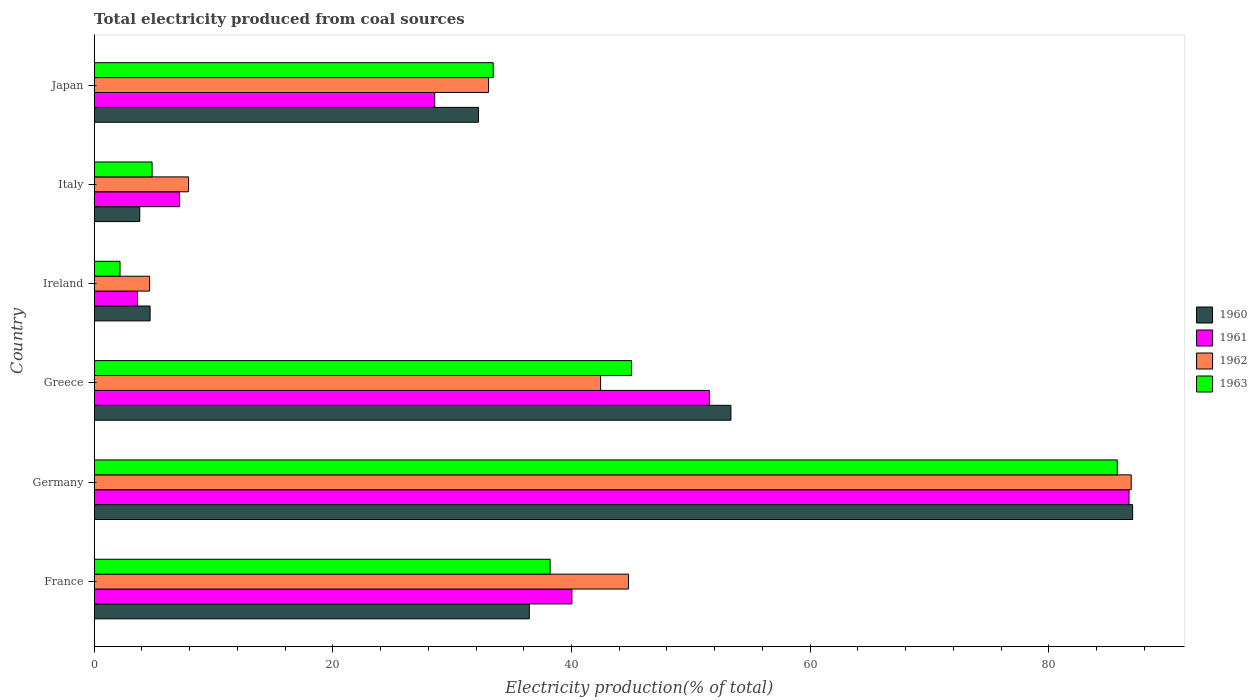How many different coloured bars are there?
Make the answer very short. 4. Are the number of bars per tick equal to the number of legend labels?
Offer a very short reply. Yes. Are the number of bars on each tick of the Y-axis equal?
Ensure brevity in your answer.  Yes. How many bars are there on the 5th tick from the top?
Keep it short and to the point. 4. What is the label of the 6th group of bars from the top?
Keep it short and to the point. France. In how many cases, is the number of bars for a given country not equal to the number of legend labels?
Offer a very short reply. 0. What is the total electricity produced in 1962 in Japan?
Offer a terse response. 33.05. Across all countries, what is the maximum total electricity produced in 1963?
Make the answer very short. 85.74. Across all countries, what is the minimum total electricity produced in 1962?
Provide a succinct answer. 4.64. In which country was the total electricity produced in 1962 maximum?
Make the answer very short. Germany. In which country was the total electricity produced in 1963 minimum?
Your answer should be very brief. Ireland. What is the total total electricity produced in 1960 in the graph?
Give a very brief answer. 217.57. What is the difference between the total electricity produced in 1961 in Greece and that in Japan?
Offer a terse response. 23.02. What is the difference between the total electricity produced in 1960 in Greece and the total electricity produced in 1961 in Germany?
Your response must be concise. -33.36. What is the average total electricity produced in 1962 per country?
Provide a short and direct response. 36.62. What is the difference between the total electricity produced in 1962 and total electricity produced in 1960 in Ireland?
Provide a succinct answer. -0.05. In how many countries, is the total electricity produced in 1963 greater than 80 %?
Make the answer very short. 1. What is the ratio of the total electricity produced in 1962 in Germany to that in Ireland?
Give a very brief answer. 18.73. Is the difference between the total electricity produced in 1962 in Ireland and Japan greater than the difference between the total electricity produced in 1960 in Ireland and Japan?
Provide a short and direct response. No. What is the difference between the highest and the second highest total electricity produced in 1962?
Provide a succinct answer. 42.13. What is the difference between the highest and the lowest total electricity produced in 1962?
Give a very brief answer. 82.27. Is the sum of the total electricity produced in 1963 in Greece and Italy greater than the maximum total electricity produced in 1960 across all countries?
Your answer should be very brief. No. How many bars are there?
Provide a short and direct response. 24. How many countries are there in the graph?
Your answer should be very brief. 6. Where does the legend appear in the graph?
Provide a short and direct response. Center right. What is the title of the graph?
Offer a very short reply. Total electricity produced from coal sources. What is the label or title of the X-axis?
Your response must be concise. Electricity production(% of total). What is the Electricity production(% of total) in 1960 in France?
Keep it short and to the point. 36.47. What is the Electricity production(% of total) in 1961 in France?
Ensure brevity in your answer.  40.03. What is the Electricity production(% of total) in 1962 in France?
Make the answer very short. 44.78. What is the Electricity production(% of total) in 1963 in France?
Offer a terse response. 38.21. What is the Electricity production(% of total) in 1960 in Germany?
Keep it short and to the point. 87.03. What is the Electricity production(% of total) in 1961 in Germany?
Make the answer very short. 86.73. What is the Electricity production(% of total) in 1962 in Germany?
Offer a terse response. 86.91. What is the Electricity production(% of total) in 1963 in Germany?
Your response must be concise. 85.74. What is the Electricity production(% of total) in 1960 in Greece?
Offer a terse response. 53.36. What is the Electricity production(% of total) of 1961 in Greece?
Provide a short and direct response. 51.56. What is the Electricity production(% of total) in 1962 in Greece?
Ensure brevity in your answer.  42.44. What is the Electricity production(% of total) in 1963 in Greece?
Make the answer very short. 45.03. What is the Electricity production(% of total) of 1960 in Ireland?
Offer a very short reply. 4.69. What is the Electricity production(% of total) of 1961 in Ireland?
Give a very brief answer. 3.63. What is the Electricity production(% of total) in 1962 in Ireland?
Offer a terse response. 4.64. What is the Electricity production(% of total) in 1963 in Ireland?
Provide a succinct answer. 2.16. What is the Electricity production(% of total) of 1960 in Italy?
Offer a terse response. 3.82. What is the Electricity production(% of total) in 1961 in Italy?
Provide a succinct answer. 7.15. What is the Electricity production(% of total) of 1962 in Italy?
Ensure brevity in your answer.  7.91. What is the Electricity production(% of total) of 1963 in Italy?
Provide a short and direct response. 4.85. What is the Electricity production(% of total) in 1960 in Japan?
Your response must be concise. 32.21. What is the Electricity production(% of total) in 1961 in Japan?
Provide a succinct answer. 28.54. What is the Electricity production(% of total) of 1962 in Japan?
Ensure brevity in your answer.  33.05. What is the Electricity production(% of total) in 1963 in Japan?
Make the answer very short. 33.44. Across all countries, what is the maximum Electricity production(% of total) of 1960?
Make the answer very short. 87.03. Across all countries, what is the maximum Electricity production(% of total) in 1961?
Offer a terse response. 86.73. Across all countries, what is the maximum Electricity production(% of total) of 1962?
Offer a very short reply. 86.91. Across all countries, what is the maximum Electricity production(% of total) in 1963?
Your answer should be very brief. 85.74. Across all countries, what is the minimum Electricity production(% of total) in 1960?
Provide a short and direct response. 3.82. Across all countries, what is the minimum Electricity production(% of total) of 1961?
Your response must be concise. 3.63. Across all countries, what is the minimum Electricity production(% of total) of 1962?
Provide a succinct answer. 4.64. Across all countries, what is the minimum Electricity production(% of total) of 1963?
Provide a succinct answer. 2.16. What is the total Electricity production(% of total) of 1960 in the graph?
Make the answer very short. 217.57. What is the total Electricity production(% of total) of 1961 in the graph?
Your answer should be compact. 217.64. What is the total Electricity production(% of total) in 1962 in the graph?
Give a very brief answer. 219.72. What is the total Electricity production(% of total) in 1963 in the graph?
Ensure brevity in your answer.  209.44. What is the difference between the Electricity production(% of total) of 1960 in France and that in Germany?
Provide a succinct answer. -50.56. What is the difference between the Electricity production(% of total) in 1961 in France and that in Germany?
Make the answer very short. -46.69. What is the difference between the Electricity production(% of total) in 1962 in France and that in Germany?
Offer a very short reply. -42.13. What is the difference between the Electricity production(% of total) in 1963 in France and that in Germany?
Offer a terse response. -47.53. What is the difference between the Electricity production(% of total) of 1960 in France and that in Greece?
Offer a terse response. -16.89. What is the difference between the Electricity production(% of total) of 1961 in France and that in Greece?
Your answer should be very brief. -11.53. What is the difference between the Electricity production(% of total) in 1962 in France and that in Greece?
Offer a very short reply. 2.34. What is the difference between the Electricity production(% of total) of 1963 in France and that in Greece?
Make the answer very short. -6.82. What is the difference between the Electricity production(% of total) of 1960 in France and that in Ireland?
Your answer should be compact. 31.78. What is the difference between the Electricity production(% of total) in 1961 in France and that in Ireland?
Offer a very short reply. 36.41. What is the difference between the Electricity production(% of total) of 1962 in France and that in Ireland?
Your answer should be very brief. 40.14. What is the difference between the Electricity production(% of total) of 1963 in France and that in Ireland?
Offer a terse response. 36.05. What is the difference between the Electricity production(% of total) in 1960 in France and that in Italy?
Keep it short and to the point. 32.65. What is the difference between the Electricity production(% of total) in 1961 in France and that in Italy?
Offer a very short reply. 32.88. What is the difference between the Electricity production(% of total) of 1962 in France and that in Italy?
Offer a very short reply. 36.87. What is the difference between the Electricity production(% of total) of 1963 in France and that in Italy?
Keep it short and to the point. 33.36. What is the difference between the Electricity production(% of total) of 1960 in France and that in Japan?
Provide a short and direct response. 4.26. What is the difference between the Electricity production(% of total) in 1961 in France and that in Japan?
Your answer should be compact. 11.5. What is the difference between the Electricity production(% of total) of 1962 in France and that in Japan?
Your response must be concise. 11.73. What is the difference between the Electricity production(% of total) of 1963 in France and that in Japan?
Provide a succinct answer. 4.77. What is the difference between the Electricity production(% of total) in 1960 in Germany and that in Greece?
Provide a short and direct response. 33.67. What is the difference between the Electricity production(% of total) in 1961 in Germany and that in Greece?
Your answer should be very brief. 35.16. What is the difference between the Electricity production(% of total) in 1962 in Germany and that in Greece?
Your answer should be compact. 44.47. What is the difference between the Electricity production(% of total) in 1963 in Germany and that in Greece?
Ensure brevity in your answer.  40.71. What is the difference between the Electricity production(% of total) in 1960 in Germany and that in Ireland?
Your response must be concise. 82.34. What is the difference between the Electricity production(% of total) in 1961 in Germany and that in Ireland?
Offer a very short reply. 83.1. What is the difference between the Electricity production(% of total) in 1962 in Germany and that in Ireland?
Make the answer very short. 82.27. What is the difference between the Electricity production(% of total) of 1963 in Germany and that in Ireland?
Make the answer very short. 83.58. What is the difference between the Electricity production(% of total) in 1960 in Germany and that in Italy?
Offer a very short reply. 83.21. What is the difference between the Electricity production(% of total) of 1961 in Germany and that in Italy?
Your answer should be compact. 79.57. What is the difference between the Electricity production(% of total) of 1962 in Germany and that in Italy?
Offer a very short reply. 79. What is the difference between the Electricity production(% of total) of 1963 in Germany and that in Italy?
Offer a very short reply. 80.89. What is the difference between the Electricity production(% of total) in 1960 in Germany and that in Japan?
Your answer should be very brief. 54.82. What is the difference between the Electricity production(% of total) of 1961 in Germany and that in Japan?
Offer a terse response. 58.19. What is the difference between the Electricity production(% of total) of 1962 in Germany and that in Japan?
Provide a succinct answer. 53.86. What is the difference between the Electricity production(% of total) in 1963 in Germany and that in Japan?
Ensure brevity in your answer.  52.3. What is the difference between the Electricity production(% of total) in 1960 in Greece and that in Ireland?
Provide a succinct answer. 48.68. What is the difference between the Electricity production(% of total) of 1961 in Greece and that in Ireland?
Provide a short and direct response. 47.93. What is the difference between the Electricity production(% of total) in 1962 in Greece and that in Ireland?
Give a very brief answer. 37.8. What is the difference between the Electricity production(% of total) of 1963 in Greece and that in Ireland?
Your answer should be very brief. 42.87. What is the difference between the Electricity production(% of total) of 1960 in Greece and that in Italy?
Give a very brief answer. 49.54. What is the difference between the Electricity production(% of total) of 1961 in Greece and that in Italy?
Offer a terse response. 44.41. What is the difference between the Electricity production(% of total) in 1962 in Greece and that in Italy?
Your answer should be compact. 34.53. What is the difference between the Electricity production(% of total) in 1963 in Greece and that in Italy?
Ensure brevity in your answer.  40.18. What is the difference between the Electricity production(% of total) in 1960 in Greece and that in Japan?
Your response must be concise. 21.15. What is the difference between the Electricity production(% of total) in 1961 in Greece and that in Japan?
Provide a short and direct response. 23.02. What is the difference between the Electricity production(% of total) in 1962 in Greece and that in Japan?
Your answer should be very brief. 9.39. What is the difference between the Electricity production(% of total) of 1963 in Greece and that in Japan?
Your answer should be very brief. 11.59. What is the difference between the Electricity production(% of total) of 1960 in Ireland and that in Italy?
Provide a short and direct response. 0.87. What is the difference between the Electricity production(% of total) in 1961 in Ireland and that in Italy?
Your answer should be very brief. -3.53. What is the difference between the Electricity production(% of total) in 1962 in Ireland and that in Italy?
Offer a terse response. -3.27. What is the difference between the Electricity production(% of total) of 1963 in Ireland and that in Italy?
Your answer should be very brief. -2.69. What is the difference between the Electricity production(% of total) in 1960 in Ireland and that in Japan?
Your answer should be very brief. -27.52. What is the difference between the Electricity production(% of total) in 1961 in Ireland and that in Japan?
Make the answer very short. -24.91. What is the difference between the Electricity production(% of total) in 1962 in Ireland and that in Japan?
Your answer should be very brief. -28.41. What is the difference between the Electricity production(% of total) in 1963 in Ireland and that in Japan?
Give a very brief answer. -31.28. What is the difference between the Electricity production(% of total) in 1960 in Italy and that in Japan?
Provide a short and direct response. -28.39. What is the difference between the Electricity production(% of total) in 1961 in Italy and that in Japan?
Your response must be concise. -21.38. What is the difference between the Electricity production(% of total) in 1962 in Italy and that in Japan?
Your answer should be very brief. -25.14. What is the difference between the Electricity production(% of total) of 1963 in Italy and that in Japan?
Provide a short and direct response. -28.59. What is the difference between the Electricity production(% of total) of 1960 in France and the Electricity production(% of total) of 1961 in Germany?
Provide a succinct answer. -50.26. What is the difference between the Electricity production(% of total) in 1960 in France and the Electricity production(% of total) in 1962 in Germany?
Provide a short and direct response. -50.44. What is the difference between the Electricity production(% of total) in 1960 in France and the Electricity production(% of total) in 1963 in Germany?
Provide a short and direct response. -49.27. What is the difference between the Electricity production(% of total) of 1961 in France and the Electricity production(% of total) of 1962 in Germany?
Give a very brief answer. -46.87. What is the difference between the Electricity production(% of total) of 1961 in France and the Electricity production(% of total) of 1963 in Germany?
Your response must be concise. -45.71. What is the difference between the Electricity production(% of total) in 1962 in France and the Electricity production(% of total) in 1963 in Germany?
Offer a terse response. -40.97. What is the difference between the Electricity production(% of total) in 1960 in France and the Electricity production(% of total) in 1961 in Greece?
Offer a terse response. -15.09. What is the difference between the Electricity production(% of total) in 1960 in France and the Electricity production(% of total) in 1962 in Greece?
Offer a very short reply. -5.97. What is the difference between the Electricity production(% of total) in 1960 in France and the Electricity production(% of total) in 1963 in Greece?
Keep it short and to the point. -8.56. What is the difference between the Electricity production(% of total) of 1961 in France and the Electricity production(% of total) of 1962 in Greece?
Provide a succinct answer. -2.41. What is the difference between the Electricity production(% of total) in 1961 in France and the Electricity production(% of total) in 1963 in Greece?
Offer a terse response. -5. What is the difference between the Electricity production(% of total) of 1962 in France and the Electricity production(% of total) of 1963 in Greece?
Make the answer very short. -0.25. What is the difference between the Electricity production(% of total) in 1960 in France and the Electricity production(% of total) in 1961 in Ireland?
Provide a short and direct response. 32.84. What is the difference between the Electricity production(% of total) of 1960 in France and the Electricity production(% of total) of 1962 in Ireland?
Give a very brief answer. 31.83. What is the difference between the Electricity production(% of total) of 1960 in France and the Electricity production(% of total) of 1963 in Ireland?
Your response must be concise. 34.3. What is the difference between the Electricity production(% of total) of 1961 in France and the Electricity production(% of total) of 1962 in Ireland?
Keep it short and to the point. 35.39. What is the difference between the Electricity production(% of total) of 1961 in France and the Electricity production(% of total) of 1963 in Ireland?
Provide a short and direct response. 37.87. What is the difference between the Electricity production(% of total) of 1962 in France and the Electricity production(% of total) of 1963 in Ireland?
Provide a succinct answer. 42.61. What is the difference between the Electricity production(% of total) in 1960 in France and the Electricity production(% of total) in 1961 in Italy?
Make the answer very short. 29.31. What is the difference between the Electricity production(% of total) in 1960 in France and the Electricity production(% of total) in 1962 in Italy?
Your response must be concise. 28.56. What is the difference between the Electricity production(% of total) in 1960 in France and the Electricity production(% of total) in 1963 in Italy?
Offer a very short reply. 31.62. What is the difference between the Electricity production(% of total) in 1961 in France and the Electricity production(% of total) in 1962 in Italy?
Give a very brief answer. 32.13. What is the difference between the Electricity production(% of total) in 1961 in France and the Electricity production(% of total) in 1963 in Italy?
Your answer should be very brief. 35.18. What is the difference between the Electricity production(% of total) of 1962 in France and the Electricity production(% of total) of 1963 in Italy?
Your answer should be very brief. 39.93. What is the difference between the Electricity production(% of total) of 1960 in France and the Electricity production(% of total) of 1961 in Japan?
Offer a terse response. 7.93. What is the difference between the Electricity production(% of total) of 1960 in France and the Electricity production(% of total) of 1962 in Japan?
Make the answer very short. 3.42. What is the difference between the Electricity production(% of total) of 1960 in France and the Electricity production(% of total) of 1963 in Japan?
Offer a very short reply. 3.02. What is the difference between the Electricity production(% of total) in 1961 in France and the Electricity production(% of total) in 1962 in Japan?
Ensure brevity in your answer.  6.99. What is the difference between the Electricity production(% of total) of 1961 in France and the Electricity production(% of total) of 1963 in Japan?
Your answer should be very brief. 6.59. What is the difference between the Electricity production(% of total) of 1962 in France and the Electricity production(% of total) of 1963 in Japan?
Provide a short and direct response. 11.33. What is the difference between the Electricity production(% of total) of 1960 in Germany and the Electricity production(% of total) of 1961 in Greece?
Provide a succinct answer. 35.47. What is the difference between the Electricity production(% of total) in 1960 in Germany and the Electricity production(% of total) in 1962 in Greece?
Provide a short and direct response. 44.59. What is the difference between the Electricity production(% of total) in 1960 in Germany and the Electricity production(% of total) in 1963 in Greece?
Ensure brevity in your answer.  42. What is the difference between the Electricity production(% of total) of 1961 in Germany and the Electricity production(% of total) of 1962 in Greece?
Offer a very short reply. 44.29. What is the difference between the Electricity production(% of total) in 1961 in Germany and the Electricity production(% of total) in 1963 in Greece?
Provide a succinct answer. 41.69. What is the difference between the Electricity production(% of total) in 1962 in Germany and the Electricity production(% of total) in 1963 in Greece?
Ensure brevity in your answer.  41.88. What is the difference between the Electricity production(% of total) of 1960 in Germany and the Electricity production(% of total) of 1961 in Ireland?
Provide a succinct answer. 83.4. What is the difference between the Electricity production(% of total) in 1960 in Germany and the Electricity production(% of total) in 1962 in Ireland?
Give a very brief answer. 82.39. What is the difference between the Electricity production(% of total) of 1960 in Germany and the Electricity production(% of total) of 1963 in Ireland?
Give a very brief answer. 84.86. What is the difference between the Electricity production(% of total) of 1961 in Germany and the Electricity production(% of total) of 1962 in Ireland?
Offer a very short reply. 82.08. What is the difference between the Electricity production(% of total) of 1961 in Germany and the Electricity production(% of total) of 1963 in Ireland?
Ensure brevity in your answer.  84.56. What is the difference between the Electricity production(% of total) of 1962 in Germany and the Electricity production(% of total) of 1963 in Ireland?
Make the answer very short. 84.74. What is the difference between the Electricity production(% of total) in 1960 in Germany and the Electricity production(% of total) in 1961 in Italy?
Make the answer very short. 79.87. What is the difference between the Electricity production(% of total) in 1960 in Germany and the Electricity production(% of total) in 1962 in Italy?
Your response must be concise. 79.12. What is the difference between the Electricity production(% of total) of 1960 in Germany and the Electricity production(% of total) of 1963 in Italy?
Your answer should be very brief. 82.18. What is the difference between the Electricity production(% of total) in 1961 in Germany and the Electricity production(% of total) in 1962 in Italy?
Make the answer very short. 78.82. What is the difference between the Electricity production(% of total) of 1961 in Germany and the Electricity production(% of total) of 1963 in Italy?
Give a very brief answer. 81.87. What is the difference between the Electricity production(% of total) of 1962 in Germany and the Electricity production(% of total) of 1963 in Italy?
Offer a very short reply. 82.06. What is the difference between the Electricity production(% of total) of 1960 in Germany and the Electricity production(% of total) of 1961 in Japan?
Your answer should be very brief. 58.49. What is the difference between the Electricity production(% of total) of 1960 in Germany and the Electricity production(% of total) of 1962 in Japan?
Your answer should be very brief. 53.98. What is the difference between the Electricity production(% of total) in 1960 in Germany and the Electricity production(% of total) in 1963 in Japan?
Keep it short and to the point. 53.59. What is the difference between the Electricity production(% of total) of 1961 in Germany and the Electricity production(% of total) of 1962 in Japan?
Provide a short and direct response. 53.68. What is the difference between the Electricity production(% of total) of 1961 in Germany and the Electricity production(% of total) of 1963 in Japan?
Provide a succinct answer. 53.28. What is the difference between the Electricity production(% of total) in 1962 in Germany and the Electricity production(% of total) in 1963 in Japan?
Your answer should be compact. 53.47. What is the difference between the Electricity production(% of total) of 1960 in Greece and the Electricity production(% of total) of 1961 in Ireland?
Your answer should be compact. 49.73. What is the difference between the Electricity production(% of total) in 1960 in Greece and the Electricity production(% of total) in 1962 in Ireland?
Your answer should be very brief. 48.72. What is the difference between the Electricity production(% of total) of 1960 in Greece and the Electricity production(% of total) of 1963 in Ireland?
Provide a succinct answer. 51.2. What is the difference between the Electricity production(% of total) of 1961 in Greece and the Electricity production(% of total) of 1962 in Ireland?
Provide a short and direct response. 46.92. What is the difference between the Electricity production(% of total) of 1961 in Greece and the Electricity production(% of total) of 1963 in Ireland?
Your answer should be compact. 49.4. What is the difference between the Electricity production(% of total) of 1962 in Greece and the Electricity production(% of total) of 1963 in Ireland?
Offer a very short reply. 40.27. What is the difference between the Electricity production(% of total) in 1960 in Greece and the Electricity production(% of total) in 1961 in Italy?
Your answer should be compact. 46.21. What is the difference between the Electricity production(% of total) in 1960 in Greece and the Electricity production(% of total) in 1962 in Italy?
Offer a terse response. 45.45. What is the difference between the Electricity production(% of total) in 1960 in Greece and the Electricity production(% of total) in 1963 in Italy?
Keep it short and to the point. 48.51. What is the difference between the Electricity production(% of total) of 1961 in Greece and the Electricity production(% of total) of 1962 in Italy?
Ensure brevity in your answer.  43.65. What is the difference between the Electricity production(% of total) of 1961 in Greece and the Electricity production(% of total) of 1963 in Italy?
Provide a short and direct response. 46.71. What is the difference between the Electricity production(% of total) of 1962 in Greece and the Electricity production(% of total) of 1963 in Italy?
Keep it short and to the point. 37.59. What is the difference between the Electricity production(% of total) of 1960 in Greece and the Electricity production(% of total) of 1961 in Japan?
Offer a terse response. 24.82. What is the difference between the Electricity production(% of total) in 1960 in Greece and the Electricity production(% of total) in 1962 in Japan?
Your answer should be compact. 20.31. What is the difference between the Electricity production(% of total) of 1960 in Greece and the Electricity production(% of total) of 1963 in Japan?
Your answer should be very brief. 19.92. What is the difference between the Electricity production(% of total) of 1961 in Greece and the Electricity production(% of total) of 1962 in Japan?
Offer a very short reply. 18.51. What is the difference between the Electricity production(% of total) in 1961 in Greece and the Electricity production(% of total) in 1963 in Japan?
Give a very brief answer. 18.12. What is the difference between the Electricity production(% of total) of 1962 in Greece and the Electricity production(% of total) of 1963 in Japan?
Offer a very short reply. 9. What is the difference between the Electricity production(% of total) of 1960 in Ireland and the Electricity production(% of total) of 1961 in Italy?
Provide a short and direct response. -2.47. What is the difference between the Electricity production(% of total) of 1960 in Ireland and the Electricity production(% of total) of 1962 in Italy?
Ensure brevity in your answer.  -3.22. What is the difference between the Electricity production(% of total) of 1960 in Ireland and the Electricity production(% of total) of 1963 in Italy?
Provide a succinct answer. -0.17. What is the difference between the Electricity production(% of total) in 1961 in Ireland and the Electricity production(% of total) in 1962 in Italy?
Offer a very short reply. -4.28. What is the difference between the Electricity production(% of total) in 1961 in Ireland and the Electricity production(% of total) in 1963 in Italy?
Provide a succinct answer. -1.22. What is the difference between the Electricity production(% of total) in 1962 in Ireland and the Electricity production(% of total) in 1963 in Italy?
Offer a very short reply. -0.21. What is the difference between the Electricity production(% of total) of 1960 in Ireland and the Electricity production(% of total) of 1961 in Japan?
Offer a very short reply. -23.85. What is the difference between the Electricity production(% of total) in 1960 in Ireland and the Electricity production(% of total) in 1962 in Japan?
Provide a short and direct response. -28.36. What is the difference between the Electricity production(% of total) of 1960 in Ireland and the Electricity production(% of total) of 1963 in Japan?
Give a very brief answer. -28.76. What is the difference between the Electricity production(% of total) of 1961 in Ireland and the Electricity production(% of total) of 1962 in Japan?
Keep it short and to the point. -29.42. What is the difference between the Electricity production(% of total) of 1961 in Ireland and the Electricity production(% of total) of 1963 in Japan?
Provide a succinct answer. -29.82. What is the difference between the Electricity production(% of total) in 1962 in Ireland and the Electricity production(% of total) in 1963 in Japan?
Ensure brevity in your answer.  -28.8. What is the difference between the Electricity production(% of total) of 1960 in Italy and the Electricity production(% of total) of 1961 in Japan?
Provide a succinct answer. -24.72. What is the difference between the Electricity production(% of total) of 1960 in Italy and the Electricity production(% of total) of 1962 in Japan?
Make the answer very short. -29.23. What is the difference between the Electricity production(% of total) in 1960 in Italy and the Electricity production(% of total) in 1963 in Japan?
Provide a short and direct response. -29.63. What is the difference between the Electricity production(% of total) of 1961 in Italy and the Electricity production(% of total) of 1962 in Japan?
Keep it short and to the point. -25.89. What is the difference between the Electricity production(% of total) of 1961 in Italy and the Electricity production(% of total) of 1963 in Japan?
Your answer should be compact. -26.29. What is the difference between the Electricity production(% of total) of 1962 in Italy and the Electricity production(% of total) of 1963 in Japan?
Offer a terse response. -25.53. What is the average Electricity production(% of total) in 1960 per country?
Provide a short and direct response. 36.26. What is the average Electricity production(% of total) of 1961 per country?
Your answer should be compact. 36.27. What is the average Electricity production(% of total) in 1962 per country?
Your response must be concise. 36.62. What is the average Electricity production(% of total) in 1963 per country?
Provide a succinct answer. 34.91. What is the difference between the Electricity production(% of total) in 1960 and Electricity production(% of total) in 1961 in France?
Ensure brevity in your answer.  -3.57. What is the difference between the Electricity production(% of total) in 1960 and Electricity production(% of total) in 1962 in France?
Give a very brief answer. -8.31. What is the difference between the Electricity production(% of total) in 1960 and Electricity production(% of total) in 1963 in France?
Offer a very short reply. -1.74. What is the difference between the Electricity production(% of total) of 1961 and Electricity production(% of total) of 1962 in France?
Your answer should be very brief. -4.74. What is the difference between the Electricity production(% of total) of 1961 and Electricity production(% of total) of 1963 in France?
Ensure brevity in your answer.  1.82. What is the difference between the Electricity production(% of total) in 1962 and Electricity production(% of total) in 1963 in France?
Give a very brief answer. 6.57. What is the difference between the Electricity production(% of total) in 1960 and Electricity production(% of total) in 1961 in Germany?
Offer a very short reply. 0.3. What is the difference between the Electricity production(% of total) of 1960 and Electricity production(% of total) of 1962 in Germany?
Provide a short and direct response. 0.12. What is the difference between the Electricity production(% of total) in 1960 and Electricity production(% of total) in 1963 in Germany?
Give a very brief answer. 1.29. What is the difference between the Electricity production(% of total) of 1961 and Electricity production(% of total) of 1962 in Germany?
Make the answer very short. -0.18. What is the difference between the Electricity production(% of total) in 1961 and Electricity production(% of total) in 1963 in Germany?
Ensure brevity in your answer.  0.98. What is the difference between the Electricity production(% of total) in 1962 and Electricity production(% of total) in 1963 in Germany?
Your answer should be compact. 1.17. What is the difference between the Electricity production(% of total) of 1960 and Electricity production(% of total) of 1961 in Greece?
Offer a very short reply. 1.8. What is the difference between the Electricity production(% of total) of 1960 and Electricity production(% of total) of 1962 in Greece?
Your response must be concise. 10.92. What is the difference between the Electricity production(% of total) of 1960 and Electricity production(% of total) of 1963 in Greece?
Provide a short and direct response. 8.33. What is the difference between the Electricity production(% of total) in 1961 and Electricity production(% of total) in 1962 in Greece?
Provide a short and direct response. 9.12. What is the difference between the Electricity production(% of total) of 1961 and Electricity production(% of total) of 1963 in Greece?
Provide a short and direct response. 6.53. What is the difference between the Electricity production(% of total) of 1962 and Electricity production(% of total) of 1963 in Greece?
Offer a terse response. -2.59. What is the difference between the Electricity production(% of total) in 1960 and Electricity production(% of total) in 1961 in Ireland?
Provide a succinct answer. 1.06. What is the difference between the Electricity production(% of total) in 1960 and Electricity production(% of total) in 1962 in Ireland?
Your response must be concise. 0.05. What is the difference between the Electricity production(% of total) of 1960 and Electricity production(% of total) of 1963 in Ireland?
Offer a terse response. 2.52. What is the difference between the Electricity production(% of total) of 1961 and Electricity production(% of total) of 1962 in Ireland?
Keep it short and to the point. -1.01. What is the difference between the Electricity production(% of total) of 1961 and Electricity production(% of total) of 1963 in Ireland?
Provide a short and direct response. 1.46. What is the difference between the Electricity production(% of total) in 1962 and Electricity production(% of total) in 1963 in Ireland?
Give a very brief answer. 2.48. What is the difference between the Electricity production(% of total) in 1960 and Electricity production(% of total) in 1961 in Italy?
Offer a terse response. -3.34. What is the difference between the Electricity production(% of total) in 1960 and Electricity production(% of total) in 1962 in Italy?
Give a very brief answer. -4.09. What is the difference between the Electricity production(% of total) in 1960 and Electricity production(% of total) in 1963 in Italy?
Make the answer very short. -1.03. What is the difference between the Electricity production(% of total) of 1961 and Electricity production(% of total) of 1962 in Italy?
Your answer should be compact. -0.75. What is the difference between the Electricity production(% of total) of 1961 and Electricity production(% of total) of 1963 in Italy?
Ensure brevity in your answer.  2.3. What is the difference between the Electricity production(% of total) in 1962 and Electricity production(% of total) in 1963 in Italy?
Give a very brief answer. 3.06. What is the difference between the Electricity production(% of total) of 1960 and Electricity production(% of total) of 1961 in Japan?
Your response must be concise. 3.67. What is the difference between the Electricity production(% of total) in 1960 and Electricity production(% of total) in 1962 in Japan?
Provide a short and direct response. -0.84. What is the difference between the Electricity production(% of total) of 1960 and Electricity production(% of total) of 1963 in Japan?
Keep it short and to the point. -1.24. What is the difference between the Electricity production(% of total) in 1961 and Electricity production(% of total) in 1962 in Japan?
Offer a terse response. -4.51. What is the difference between the Electricity production(% of total) in 1961 and Electricity production(% of total) in 1963 in Japan?
Ensure brevity in your answer.  -4.9. What is the difference between the Electricity production(% of total) in 1962 and Electricity production(% of total) in 1963 in Japan?
Offer a terse response. -0.4. What is the ratio of the Electricity production(% of total) of 1960 in France to that in Germany?
Provide a succinct answer. 0.42. What is the ratio of the Electricity production(% of total) of 1961 in France to that in Germany?
Provide a short and direct response. 0.46. What is the ratio of the Electricity production(% of total) of 1962 in France to that in Germany?
Your answer should be compact. 0.52. What is the ratio of the Electricity production(% of total) in 1963 in France to that in Germany?
Provide a short and direct response. 0.45. What is the ratio of the Electricity production(% of total) of 1960 in France to that in Greece?
Your answer should be compact. 0.68. What is the ratio of the Electricity production(% of total) of 1961 in France to that in Greece?
Keep it short and to the point. 0.78. What is the ratio of the Electricity production(% of total) in 1962 in France to that in Greece?
Provide a succinct answer. 1.06. What is the ratio of the Electricity production(% of total) of 1963 in France to that in Greece?
Your response must be concise. 0.85. What is the ratio of the Electricity production(% of total) of 1960 in France to that in Ireland?
Keep it short and to the point. 7.78. What is the ratio of the Electricity production(% of total) of 1961 in France to that in Ireland?
Give a very brief answer. 11.03. What is the ratio of the Electricity production(% of total) in 1962 in France to that in Ireland?
Provide a succinct answer. 9.65. What is the ratio of the Electricity production(% of total) of 1963 in France to that in Ireland?
Provide a short and direct response. 17.65. What is the ratio of the Electricity production(% of total) in 1960 in France to that in Italy?
Make the answer very short. 9.55. What is the ratio of the Electricity production(% of total) in 1961 in France to that in Italy?
Your answer should be very brief. 5.6. What is the ratio of the Electricity production(% of total) in 1962 in France to that in Italy?
Your answer should be compact. 5.66. What is the ratio of the Electricity production(% of total) of 1963 in France to that in Italy?
Give a very brief answer. 7.88. What is the ratio of the Electricity production(% of total) of 1960 in France to that in Japan?
Offer a very short reply. 1.13. What is the ratio of the Electricity production(% of total) in 1961 in France to that in Japan?
Provide a short and direct response. 1.4. What is the ratio of the Electricity production(% of total) in 1962 in France to that in Japan?
Provide a short and direct response. 1.35. What is the ratio of the Electricity production(% of total) of 1963 in France to that in Japan?
Give a very brief answer. 1.14. What is the ratio of the Electricity production(% of total) in 1960 in Germany to that in Greece?
Offer a very short reply. 1.63. What is the ratio of the Electricity production(% of total) of 1961 in Germany to that in Greece?
Make the answer very short. 1.68. What is the ratio of the Electricity production(% of total) of 1962 in Germany to that in Greece?
Give a very brief answer. 2.05. What is the ratio of the Electricity production(% of total) of 1963 in Germany to that in Greece?
Ensure brevity in your answer.  1.9. What is the ratio of the Electricity production(% of total) in 1960 in Germany to that in Ireland?
Provide a succinct answer. 18.57. What is the ratio of the Electricity production(% of total) in 1961 in Germany to that in Ireland?
Give a very brief answer. 23.9. What is the ratio of the Electricity production(% of total) of 1962 in Germany to that in Ireland?
Provide a succinct answer. 18.73. What is the ratio of the Electricity production(% of total) of 1963 in Germany to that in Ireland?
Make the answer very short. 39.6. What is the ratio of the Electricity production(% of total) of 1960 in Germany to that in Italy?
Give a very brief answer. 22.79. What is the ratio of the Electricity production(% of total) in 1961 in Germany to that in Italy?
Provide a short and direct response. 12.12. What is the ratio of the Electricity production(% of total) in 1962 in Germany to that in Italy?
Offer a terse response. 10.99. What is the ratio of the Electricity production(% of total) of 1963 in Germany to that in Italy?
Provide a short and direct response. 17.67. What is the ratio of the Electricity production(% of total) of 1960 in Germany to that in Japan?
Offer a very short reply. 2.7. What is the ratio of the Electricity production(% of total) of 1961 in Germany to that in Japan?
Give a very brief answer. 3.04. What is the ratio of the Electricity production(% of total) of 1962 in Germany to that in Japan?
Keep it short and to the point. 2.63. What is the ratio of the Electricity production(% of total) in 1963 in Germany to that in Japan?
Provide a short and direct response. 2.56. What is the ratio of the Electricity production(% of total) of 1960 in Greece to that in Ireland?
Offer a terse response. 11.39. What is the ratio of the Electricity production(% of total) in 1961 in Greece to that in Ireland?
Make the answer very short. 14.21. What is the ratio of the Electricity production(% of total) in 1962 in Greece to that in Ireland?
Offer a terse response. 9.14. What is the ratio of the Electricity production(% of total) in 1963 in Greece to that in Ireland?
Keep it short and to the point. 20.8. What is the ratio of the Electricity production(% of total) of 1960 in Greece to that in Italy?
Give a very brief answer. 13.97. What is the ratio of the Electricity production(% of total) in 1961 in Greece to that in Italy?
Your answer should be very brief. 7.21. What is the ratio of the Electricity production(% of total) of 1962 in Greece to that in Italy?
Keep it short and to the point. 5.37. What is the ratio of the Electricity production(% of total) in 1963 in Greece to that in Italy?
Your answer should be very brief. 9.28. What is the ratio of the Electricity production(% of total) in 1960 in Greece to that in Japan?
Offer a terse response. 1.66. What is the ratio of the Electricity production(% of total) of 1961 in Greece to that in Japan?
Provide a short and direct response. 1.81. What is the ratio of the Electricity production(% of total) of 1962 in Greece to that in Japan?
Ensure brevity in your answer.  1.28. What is the ratio of the Electricity production(% of total) in 1963 in Greece to that in Japan?
Offer a very short reply. 1.35. What is the ratio of the Electricity production(% of total) in 1960 in Ireland to that in Italy?
Make the answer very short. 1.23. What is the ratio of the Electricity production(% of total) in 1961 in Ireland to that in Italy?
Offer a terse response. 0.51. What is the ratio of the Electricity production(% of total) in 1962 in Ireland to that in Italy?
Keep it short and to the point. 0.59. What is the ratio of the Electricity production(% of total) of 1963 in Ireland to that in Italy?
Your response must be concise. 0.45. What is the ratio of the Electricity production(% of total) of 1960 in Ireland to that in Japan?
Provide a succinct answer. 0.15. What is the ratio of the Electricity production(% of total) in 1961 in Ireland to that in Japan?
Your response must be concise. 0.13. What is the ratio of the Electricity production(% of total) in 1962 in Ireland to that in Japan?
Provide a succinct answer. 0.14. What is the ratio of the Electricity production(% of total) in 1963 in Ireland to that in Japan?
Keep it short and to the point. 0.06. What is the ratio of the Electricity production(% of total) in 1960 in Italy to that in Japan?
Ensure brevity in your answer.  0.12. What is the ratio of the Electricity production(% of total) in 1961 in Italy to that in Japan?
Provide a short and direct response. 0.25. What is the ratio of the Electricity production(% of total) of 1962 in Italy to that in Japan?
Your response must be concise. 0.24. What is the ratio of the Electricity production(% of total) of 1963 in Italy to that in Japan?
Ensure brevity in your answer.  0.15. What is the difference between the highest and the second highest Electricity production(% of total) in 1960?
Keep it short and to the point. 33.67. What is the difference between the highest and the second highest Electricity production(% of total) in 1961?
Your answer should be compact. 35.16. What is the difference between the highest and the second highest Electricity production(% of total) in 1962?
Offer a very short reply. 42.13. What is the difference between the highest and the second highest Electricity production(% of total) of 1963?
Ensure brevity in your answer.  40.71. What is the difference between the highest and the lowest Electricity production(% of total) in 1960?
Make the answer very short. 83.21. What is the difference between the highest and the lowest Electricity production(% of total) of 1961?
Your response must be concise. 83.1. What is the difference between the highest and the lowest Electricity production(% of total) in 1962?
Ensure brevity in your answer.  82.27. What is the difference between the highest and the lowest Electricity production(% of total) in 1963?
Ensure brevity in your answer.  83.58. 